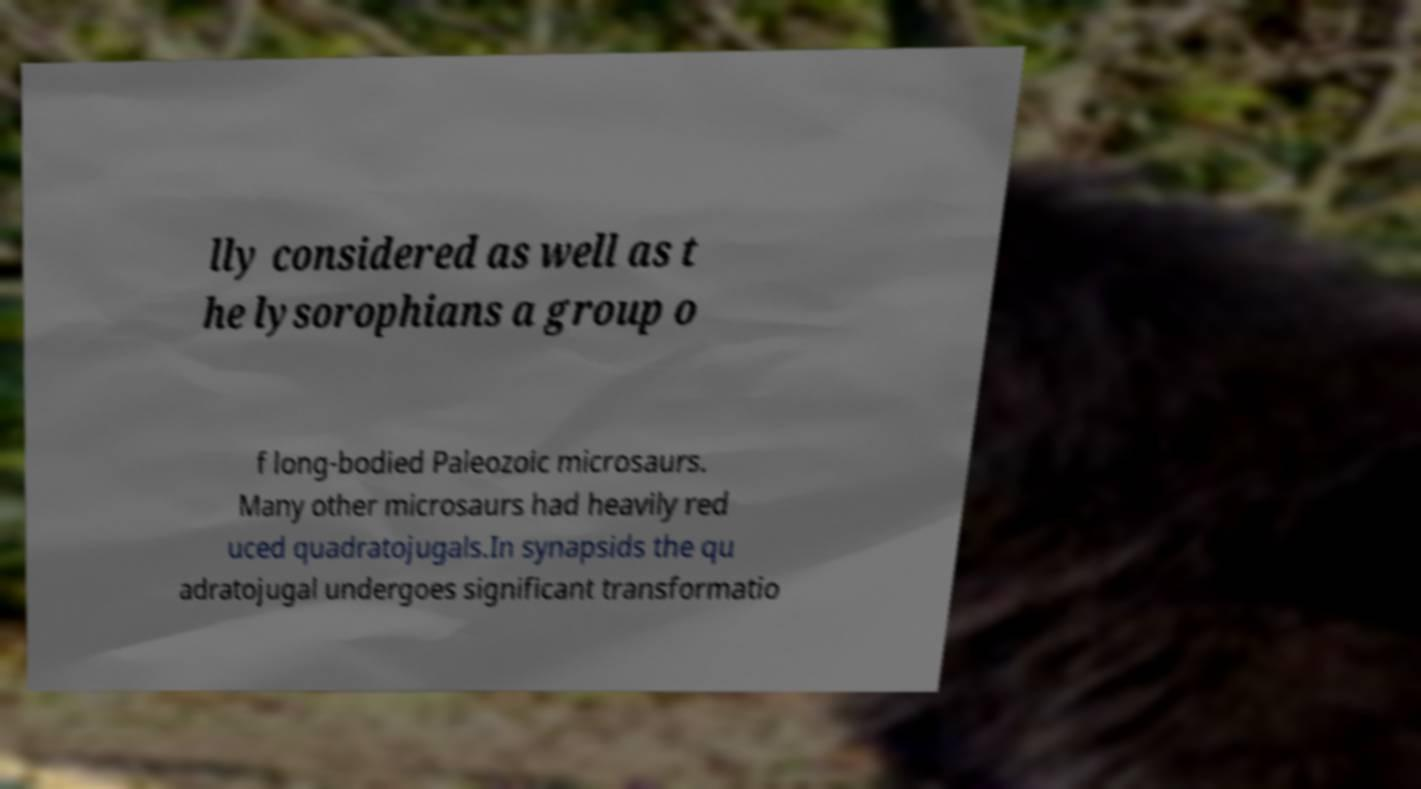Please identify and transcribe the text found in this image. lly considered as well as t he lysorophians a group o f long-bodied Paleozoic microsaurs. Many other microsaurs had heavily red uced quadratojugals.In synapsids the qu adratojugal undergoes significant transformatio 